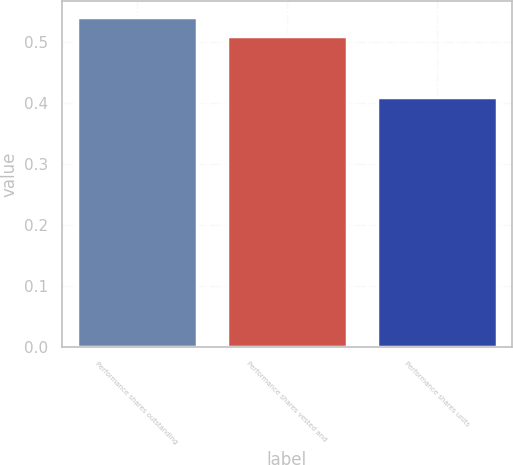Convert chart. <chart><loc_0><loc_0><loc_500><loc_500><bar_chart><fcel>Performance shares outstanding<fcel>Performance shares vested and<fcel>Performance shares units<nl><fcel>0.54<fcel>0.51<fcel>0.41<nl></chart> 